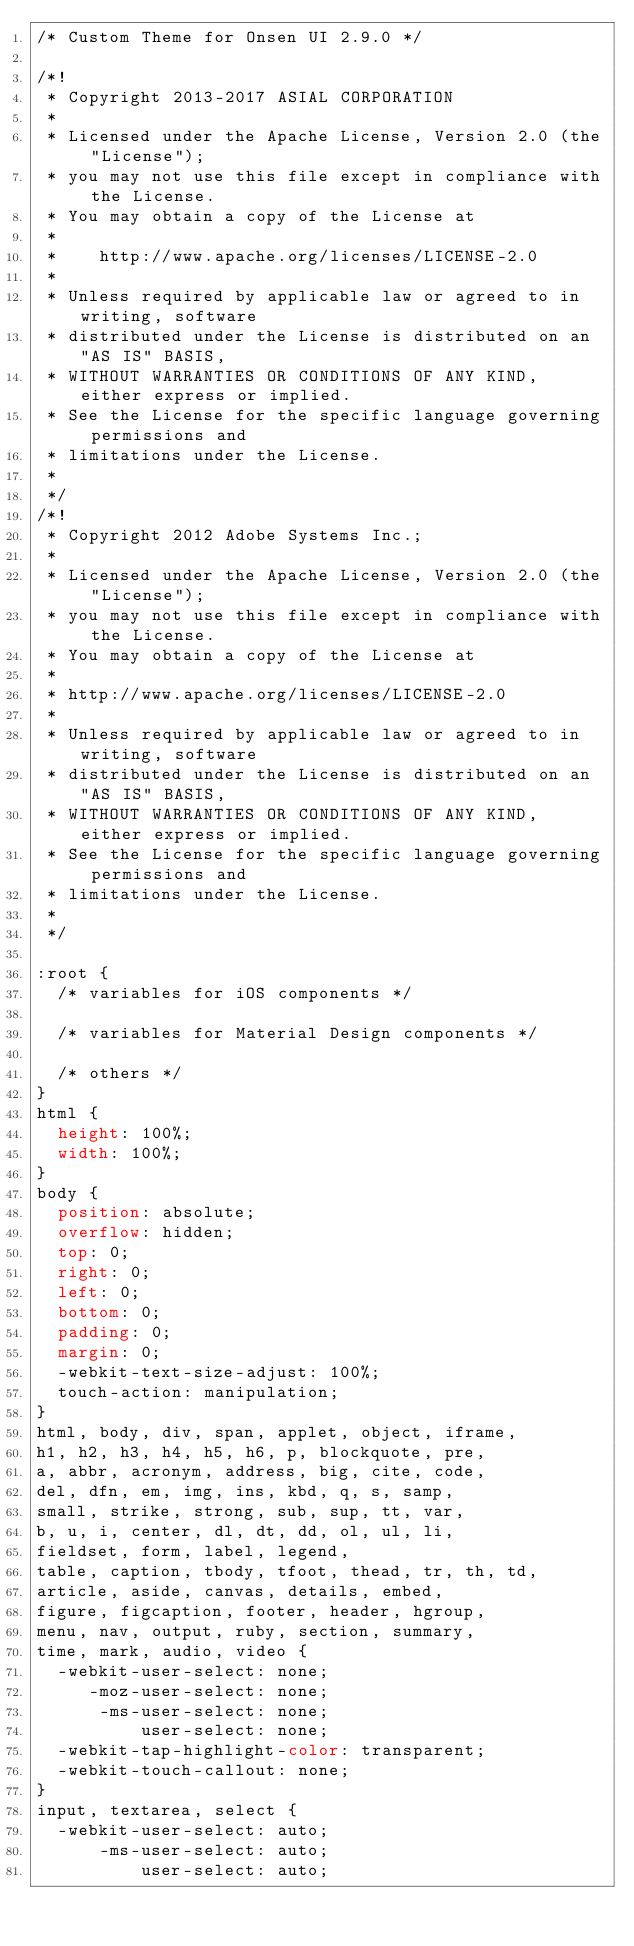<code> <loc_0><loc_0><loc_500><loc_500><_CSS_>/* Custom Theme for Onsen UI 2.9.0 */

/*!
 * Copyright 2013-2017 ASIAL CORPORATION
 *
 * Licensed under the Apache License, Version 2.0 (the "License");
 * you may not use this file except in compliance with the License.
 * You may obtain a copy of the License at
 *
 *    http://www.apache.org/licenses/LICENSE-2.0
 *
 * Unless required by applicable law or agreed to in writing, software
 * distributed under the License is distributed on an "AS IS" BASIS,
 * WITHOUT WARRANTIES OR CONDITIONS OF ANY KIND, either express or implied.
 * See the License for the specific language governing permissions and
 * limitations under the License.
 *
 */
/*!
 * Copyright 2012 Adobe Systems Inc.;
 *
 * Licensed under the Apache License, Version 2.0 (the "License");
 * you may not use this file except in compliance with the License.
 * You may obtain a copy of the License at
 *
 * http://www.apache.org/licenses/LICENSE-2.0
 *
 * Unless required by applicable law or agreed to in writing, software
 * distributed under the License is distributed on an "AS IS" BASIS,
 * WITHOUT WARRANTIES OR CONDITIONS OF ANY KIND, either express or implied.
 * See the License for the specific language governing permissions and
 * limitations under the License.
 *
 */

:root {
  /* variables for iOS components */

  /* variables for Material Design components */

  /* others */
}
html {
  height: 100%;
  width: 100%;
}
body {
  position: absolute;
  overflow: hidden;
  top: 0;
  right: 0;
  left: 0;
  bottom: 0;
  padding: 0;
  margin: 0;
  -webkit-text-size-adjust: 100%;
  touch-action: manipulation;
}
html, body, div, span, applet, object, iframe,
h1, h2, h3, h4, h5, h6, p, blockquote, pre,
a, abbr, acronym, address, big, cite, code,
del, dfn, em, img, ins, kbd, q, s, samp,
small, strike, strong, sub, sup, tt, var,
b, u, i, center, dl, dt, dd, ol, ul, li,
fieldset, form, label, legend,
table, caption, tbody, tfoot, thead, tr, th, td,
article, aside, canvas, details, embed,
figure, figcaption, footer, header, hgroup,
menu, nav, output, ruby, section, summary,
time, mark, audio, video {
  -webkit-user-select: none;
     -moz-user-select: none;
      -ms-user-select: none;
          user-select: none;
  -webkit-tap-highlight-color: transparent;
  -webkit-touch-callout: none;
}
input, textarea, select {
  -webkit-user-select: auto;
      -ms-user-select: auto;
          user-select: auto;</code> 